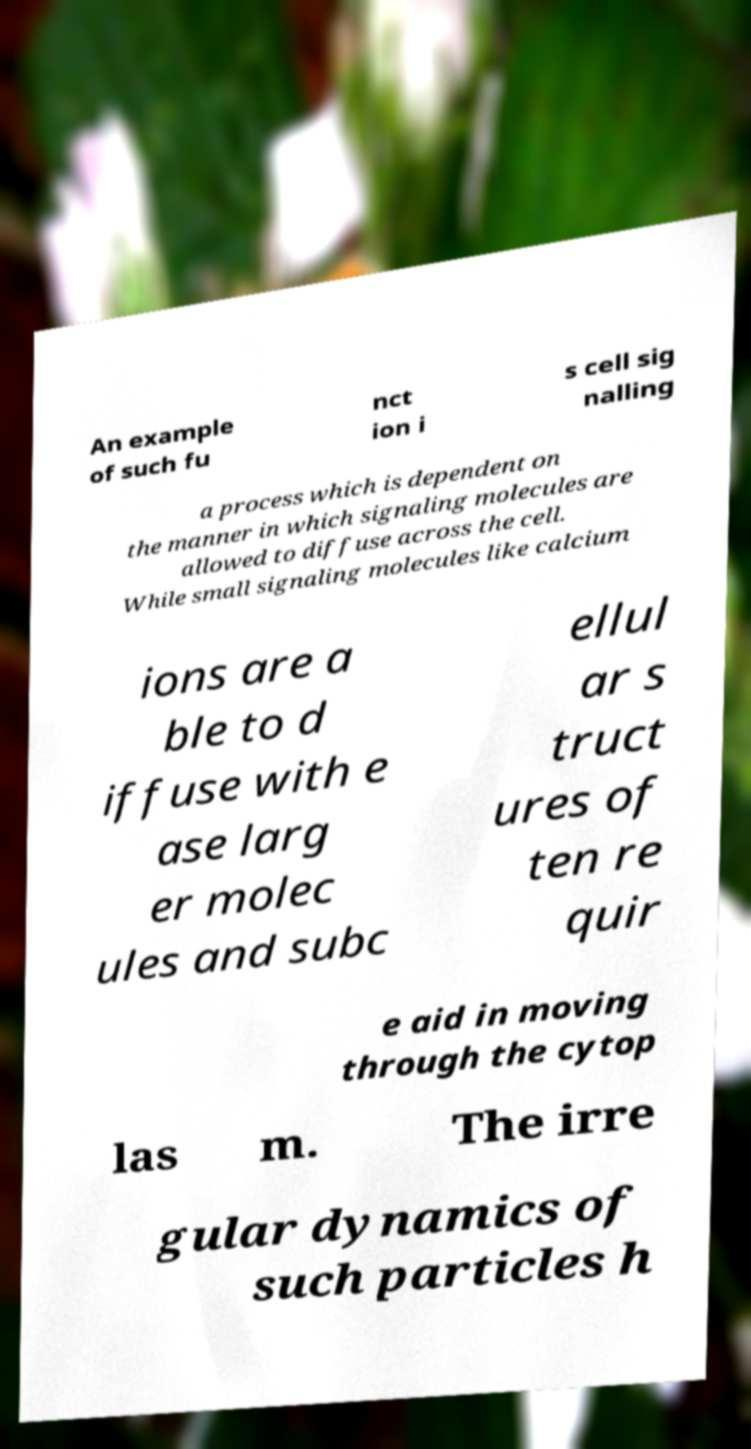Can you read and provide the text displayed in the image?This photo seems to have some interesting text. Can you extract and type it out for me? An example of such fu nct ion i s cell sig nalling a process which is dependent on the manner in which signaling molecules are allowed to diffuse across the cell. While small signaling molecules like calcium ions are a ble to d iffuse with e ase larg er molec ules and subc ellul ar s truct ures of ten re quir e aid in moving through the cytop las m. The irre gular dynamics of such particles h 